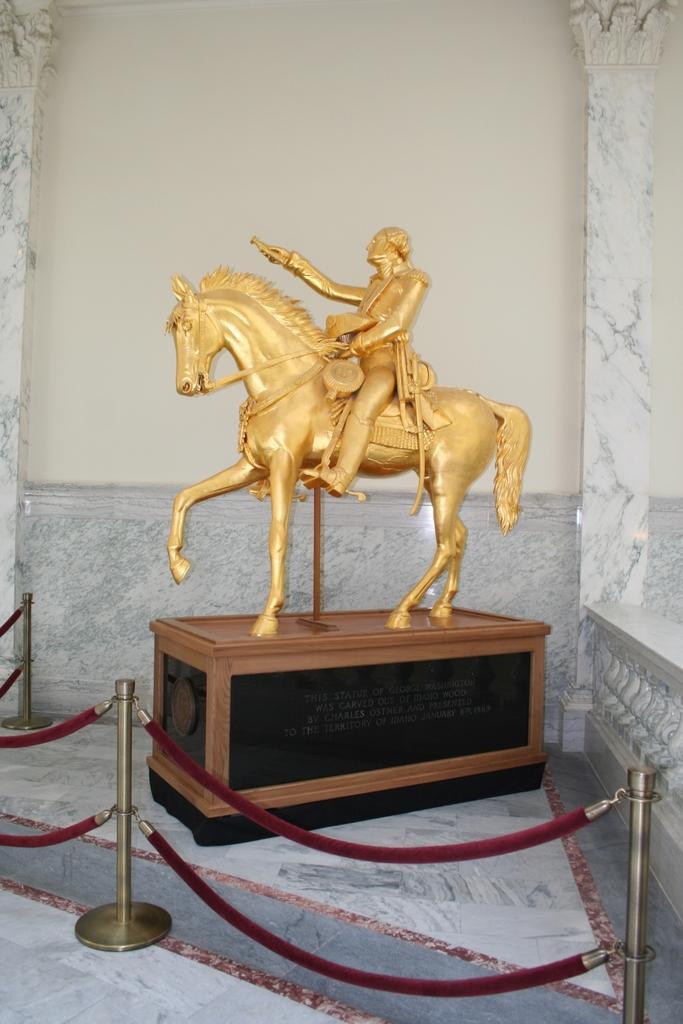Could you give a brief overview of what you see in this image? In the image there is a statue of a man riding horse on a wooden block inside a fence and behind it, its a wall. 